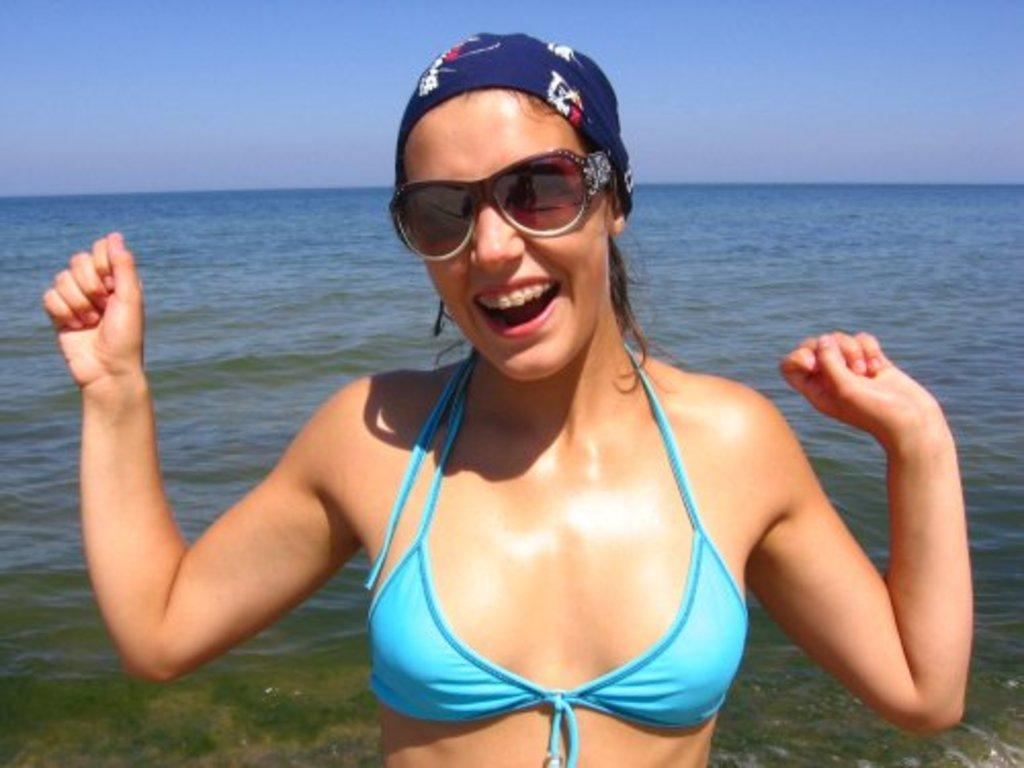What is the main subject in the foreground of the image? There is a woman in the foreground of the image. What is the woman doing in the image? The woman has an open mouth, which might suggest she is speaking or singing. What accessories is the woman wearing in the image? The woman is wearing spectacles and a headband. What can be seen in the background of the image? Water and the sky are visible in the background of the image. What type of apple is the woman holding in the image? There is no apple present in the image. How is the woman using the fork in the image? There is no fork present in the image. 